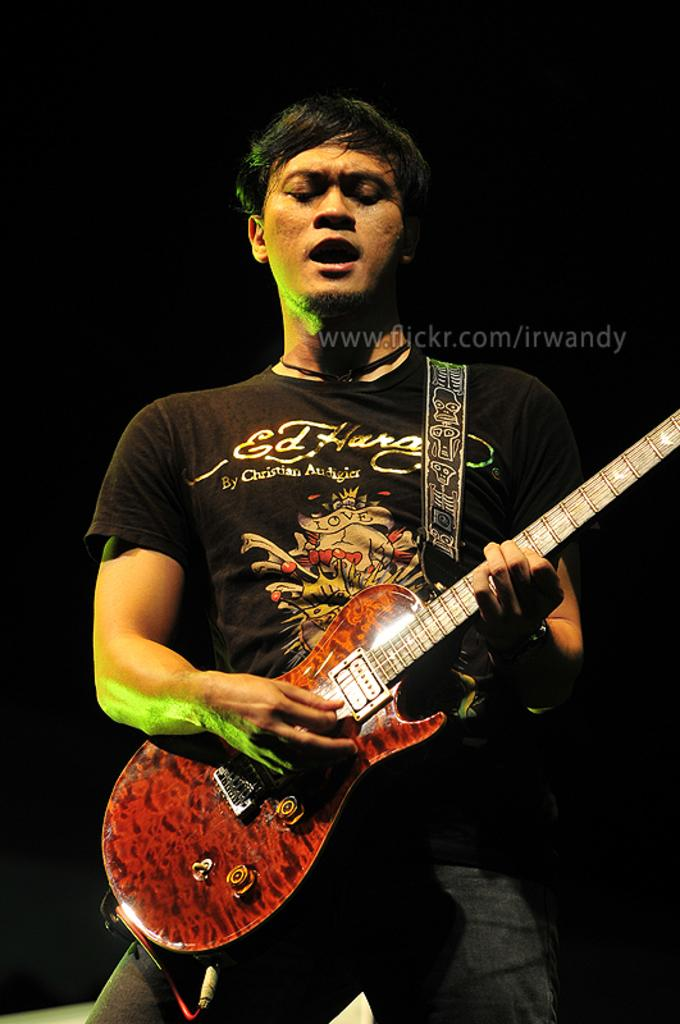What is the main subject of the image? There is a man in the image. What is the man doing in the image? The man is standing and playing a guitar. Is the man performing any other actions in the image? Yes, the man is singing a song, as indicated by his mouth movement. What type of pipe can be seen in the man's hand in the image? There is no pipe present in the man's hand or in the image. What does the man's dad think about his performance in the image? The image does not provide any information about the man's dad or his opinion on the man's performance. 